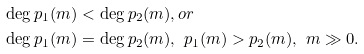Convert formula to latex. <formula><loc_0><loc_0><loc_500><loc_500>\deg p _ { 1 } ( m ) & < \deg p _ { 2 } ( m ) , o r \\ \deg p _ { 1 } ( m ) & = \deg p _ { 2 } ( m ) , \ p _ { 1 } ( m ) > p _ { 2 } ( m ) , \ m \gg 0 .</formula> 